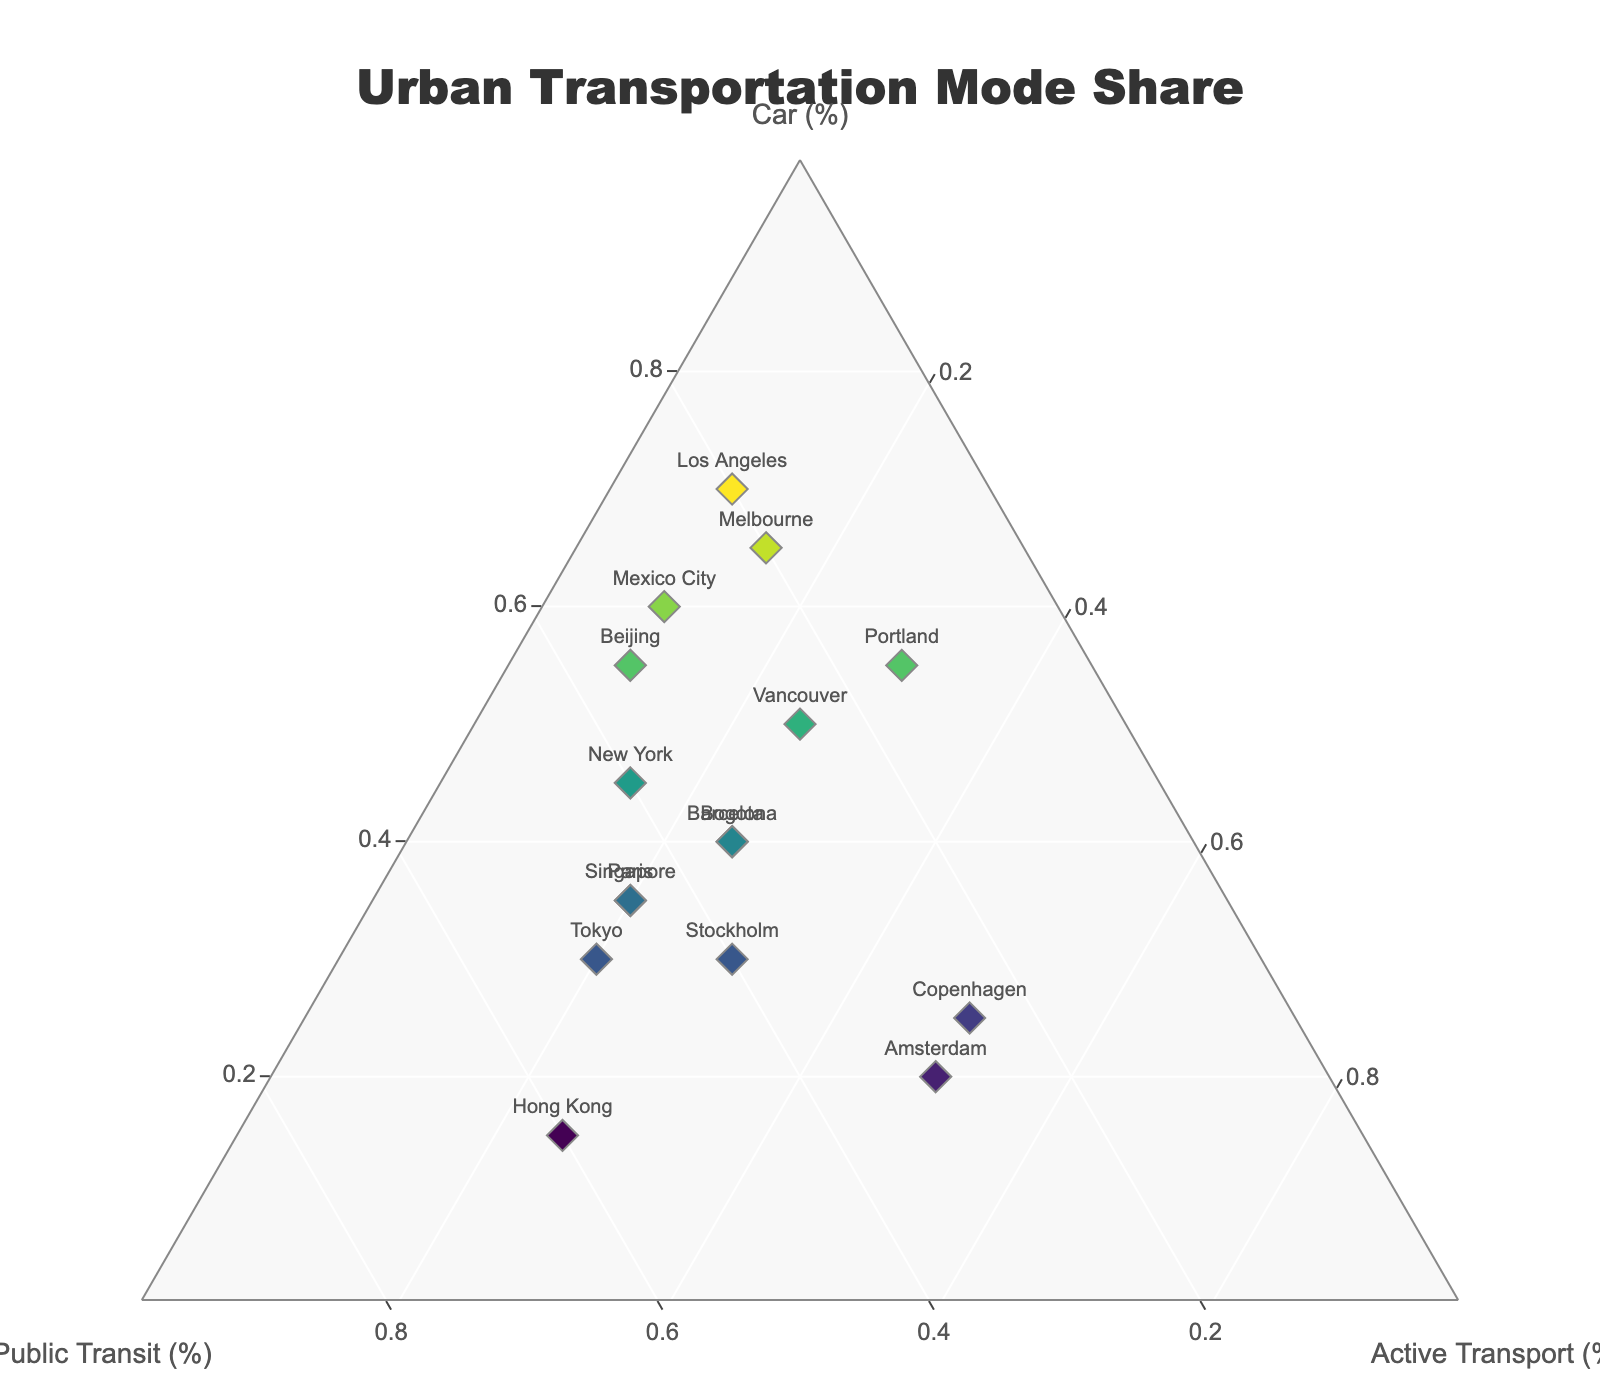What is the title of the figure? The title is displayed prominently at the top of the figure.
Answer: Urban Transportation Mode Share How many cities are represented on the plot? By counting the different markers or labels on the plot, we can determine the number of cities.
Answer: 16 Which city has the highest share of public transit? By examining the markers positioned closest to the corner labeled as Public Transit (%), we observe that this corresponds to the highest public transit share.
Answer: Hong Kong Which category has the highest share for Copenhagen? By locating Copenhagen on the plot and noting the position relative to the three axes, we determine the dominant category.
Answer: Active Transport Which city has the largest share of car usage? By examining the markers closest to the corner labeled as Car (%), we identify the city with the highest car usage share.
Answer: Los Angeles What is the combined share of active transport and public transit for Amsterdam? Summing up the share values of active transport and public transit for Amsterdam provides the combined share.
Answer: 80% Is Hong Kong’s share of active transport greater or less than that of Paris? By comparing their respective positions and values in the active transport dimension, we determine the greater share.
Answer: Greater Which cities have the same highest share for active transport? By identifying markers that position equally or very close to the Active Transport (%) corner, we see which cities share this characteristic.
Answer: Amsterdam and Copenhagen Does New York have a higher share of public transit or active transport? Checking New York's values in the public transit and active transport dimensions, we compare them directly.
Answer: Public Transit Which city is more balanced between transportation modes: Portland or Vancouver? By observing the positions relative to the center of the plot, we identify which city has more equal proportions across all three modes.
Answer: Vancouver Which city has the closest share between cars and public transit? Finding the city positioned almost equidistantly between the Car (%) and Public Transit (%) axes indicates close shares.
Answer: Barcelona 